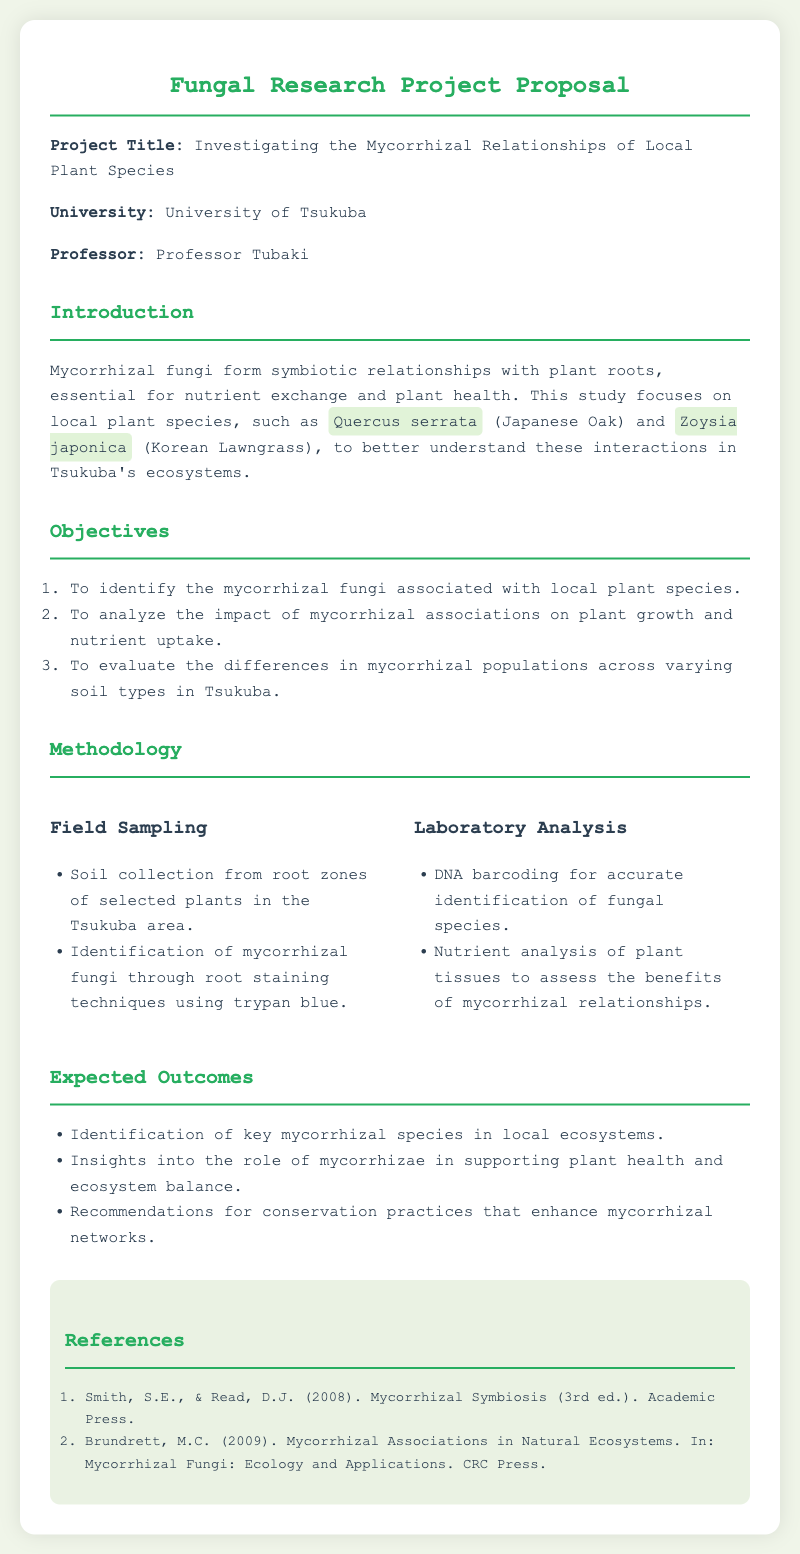what is the project title? The project title is clearly stated in the document as the main focus of the proposal.
Answer: Investigating the Mycorrhizal Relationships of Local Plant Species who is the professor supervising the project? The document mentions the supervisor's name alongside the university.
Answer: Professor Tubaki what two local plant species are studied in this research? The document lists specific plant species that are the focus of the research within the introduction section.
Answer: Quercus serrata and Zoysia japonica how many objectives are there in the project? The document outlines the objectives as a numbered list, providing a clear count.
Answer: 3 what method is used for identifying mycorrhizal fungi in the field? The methodology section describes the techniques applied in field sampling specifically related to this research.
Answer: Root staining techniques using trypan blue what analysis method will be employed to identify fungal species? The laboratory analysis segment of the methodology provides insight into the techniques utilized for identification.
Answer: DNA barcoding name one expected outcome of the research. The document lists specific outcomes that are anticipated from the project to summarize its significance.
Answer: Identification of key mycorrhizal species in local ecosystems how many references are listed in the document? The references section shows a count of the sources cited in support of the research proposal.
Answer: 2 